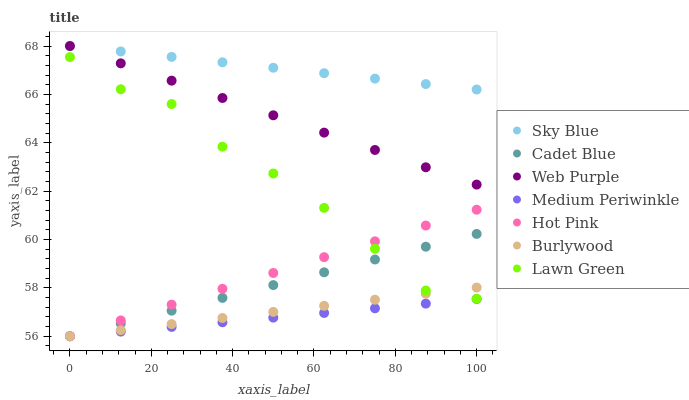Does Medium Periwinkle have the minimum area under the curve?
Answer yes or no. Yes. Does Sky Blue have the maximum area under the curve?
Answer yes or no. Yes. Does Cadet Blue have the minimum area under the curve?
Answer yes or no. No. Does Cadet Blue have the maximum area under the curve?
Answer yes or no. No. Is Sky Blue the smoothest?
Answer yes or no. Yes. Is Lawn Green the roughest?
Answer yes or no. Yes. Is Cadet Blue the smoothest?
Answer yes or no. No. Is Cadet Blue the roughest?
Answer yes or no. No. Does Cadet Blue have the lowest value?
Answer yes or no. Yes. Does Web Purple have the lowest value?
Answer yes or no. No. Does Sky Blue have the highest value?
Answer yes or no. Yes. Does Cadet Blue have the highest value?
Answer yes or no. No. Is Medium Periwinkle less than Sky Blue?
Answer yes or no. Yes. Is Sky Blue greater than Cadet Blue?
Answer yes or no. Yes. Does Burlywood intersect Medium Periwinkle?
Answer yes or no. Yes. Is Burlywood less than Medium Periwinkle?
Answer yes or no. No. Is Burlywood greater than Medium Periwinkle?
Answer yes or no. No. Does Medium Periwinkle intersect Sky Blue?
Answer yes or no. No. 